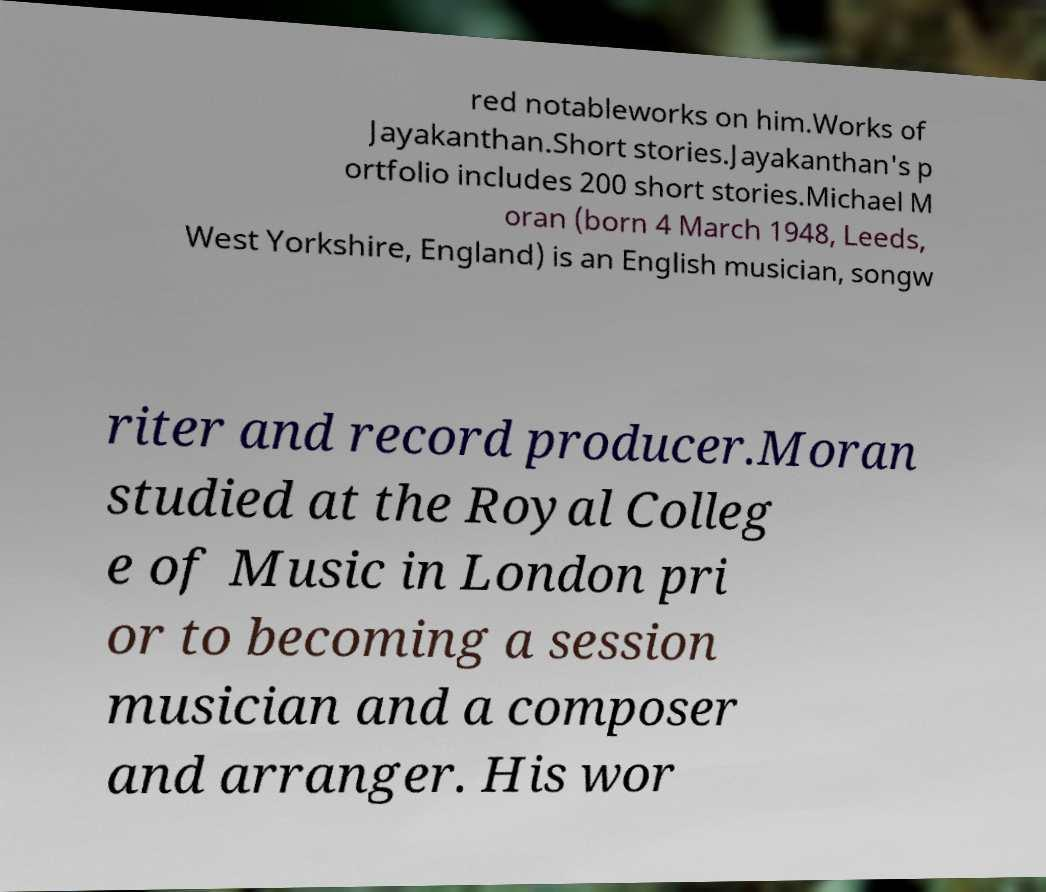For documentation purposes, I need the text within this image transcribed. Could you provide that? red notableworks on him.Works of Jayakanthan.Short stories.Jayakanthan's p ortfolio includes 200 short stories.Michael M oran (born 4 March 1948, Leeds, West Yorkshire, England) is an English musician, songw riter and record producer.Moran studied at the Royal Colleg e of Music in London pri or to becoming a session musician and a composer and arranger. His wor 